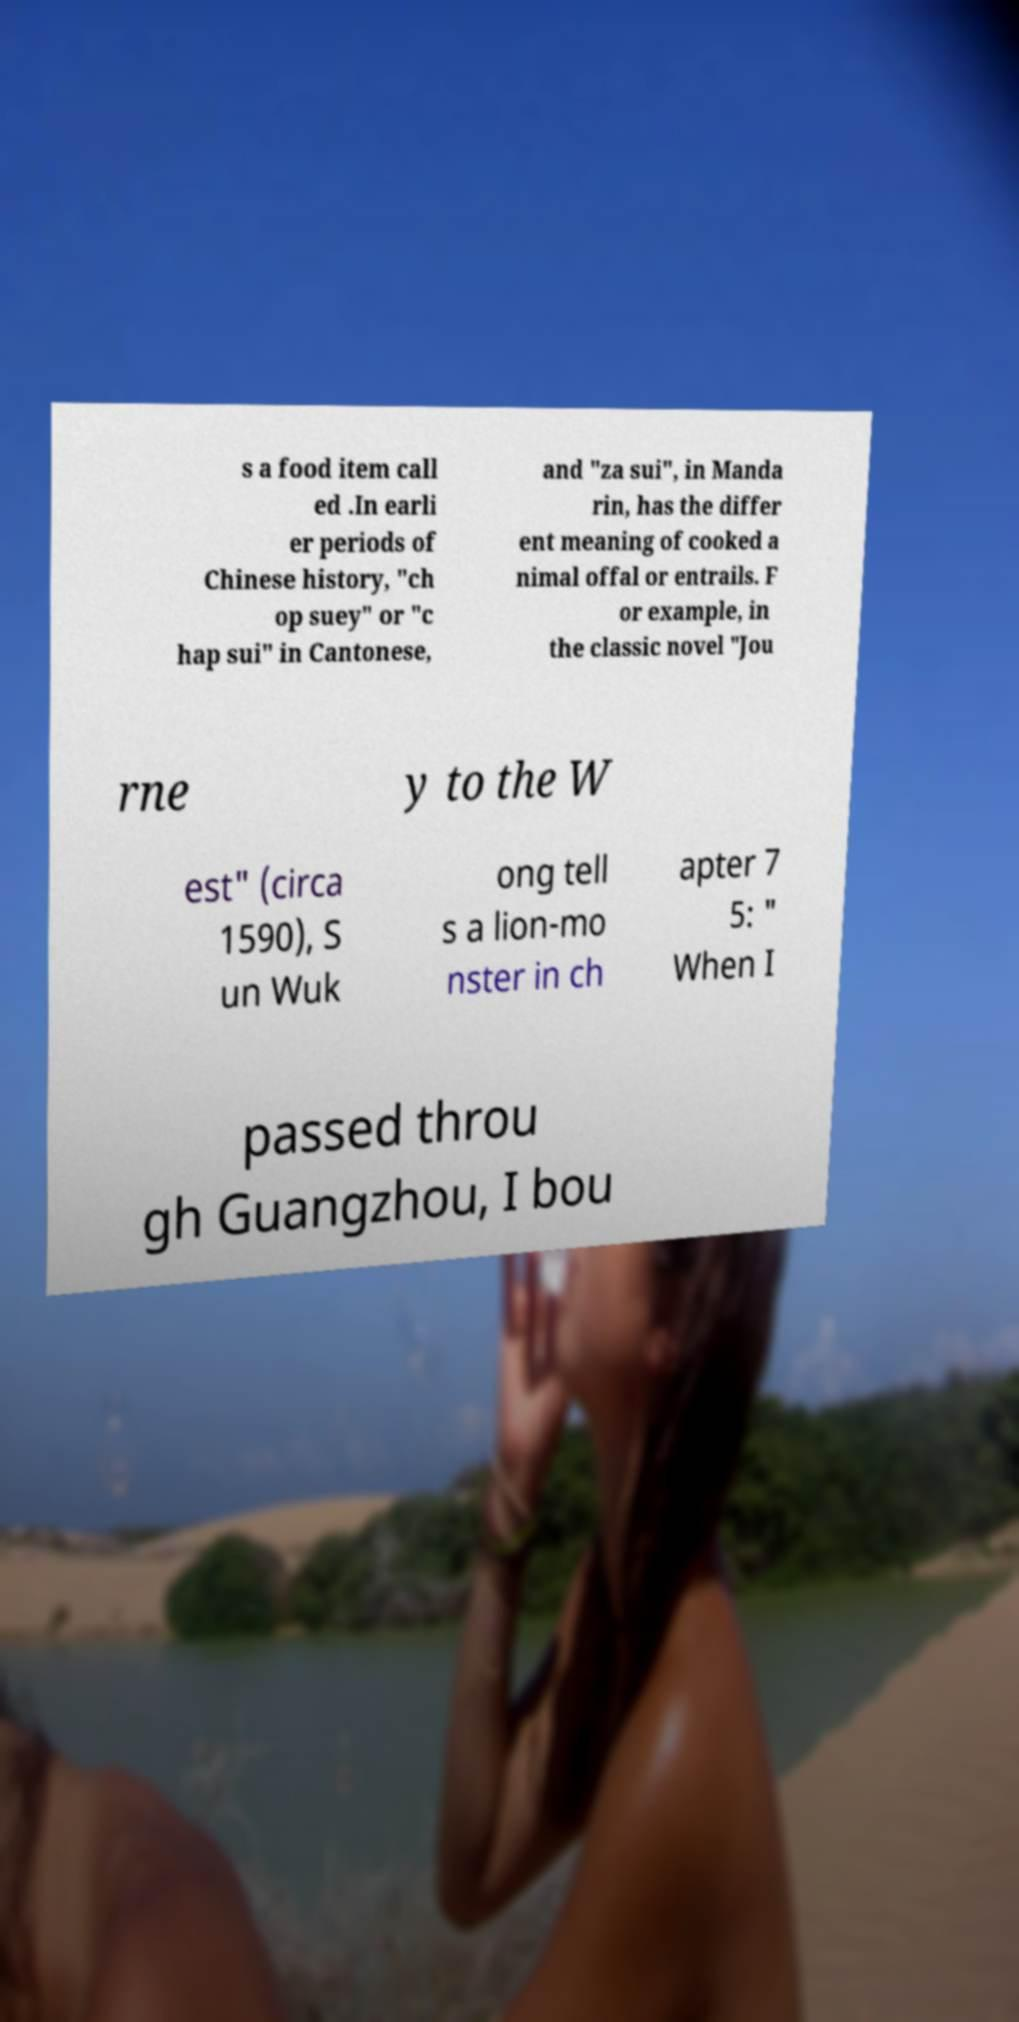For documentation purposes, I need the text within this image transcribed. Could you provide that? s a food item call ed .In earli er periods of Chinese history, "ch op suey" or "c hap sui" in Cantonese, and "za sui", in Manda rin, has the differ ent meaning of cooked a nimal offal or entrails. F or example, in the classic novel "Jou rne y to the W est" (circa 1590), S un Wuk ong tell s a lion-mo nster in ch apter 7 5: " When I passed throu gh Guangzhou, I bou 